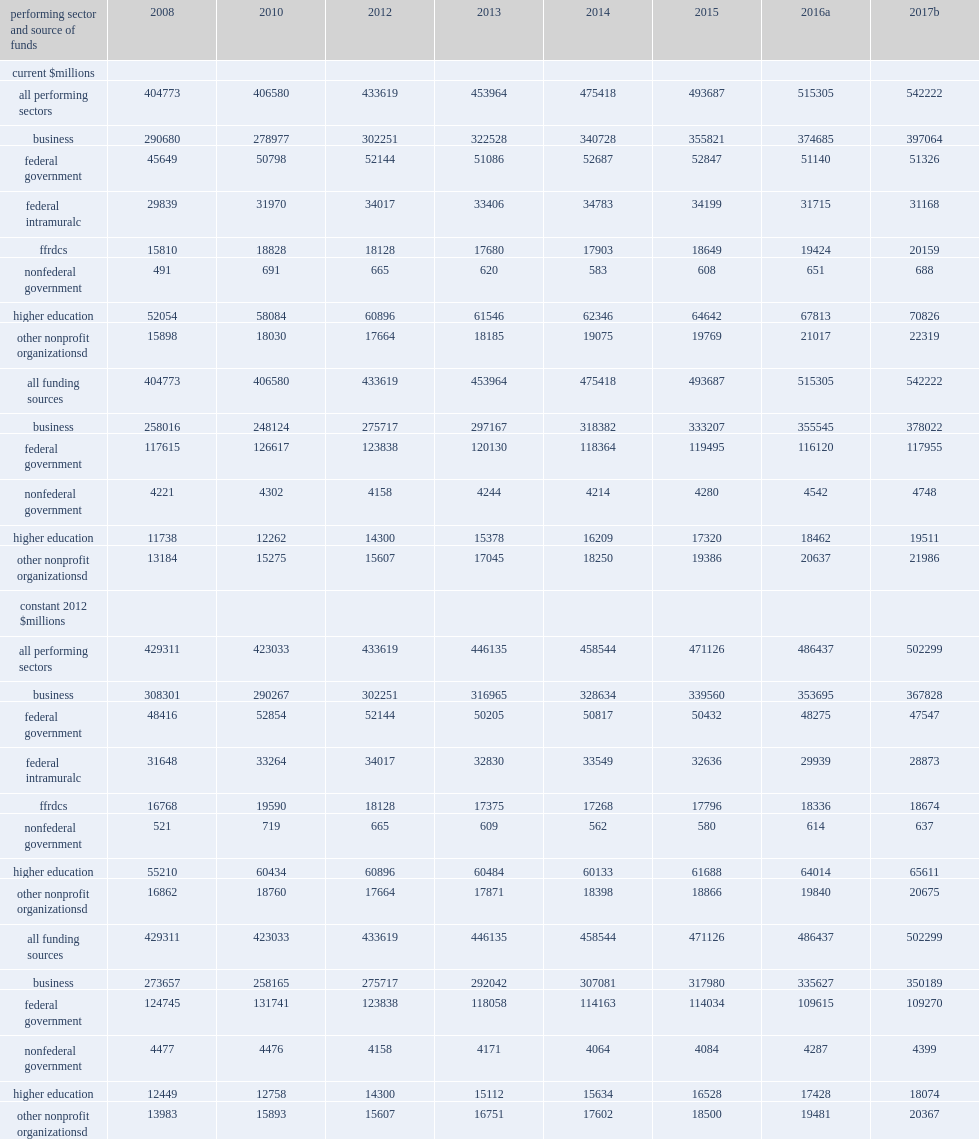How many million dollars did research and experimental development perform in the united states totaled in 2016? 515305.0. How many million dollars is the estimated total for 2017, based on performer-reported expectations? 542222.0. What is the numbers of million dollars compared with u.s. r&d totals in 2013? 453964.0. What is the numbers of million dollars compared with u.s. r&d totals in 2014? 475418.0. What is the numbers of million dollars compared with u.s. r&d totals in 2015? 493687.0. 